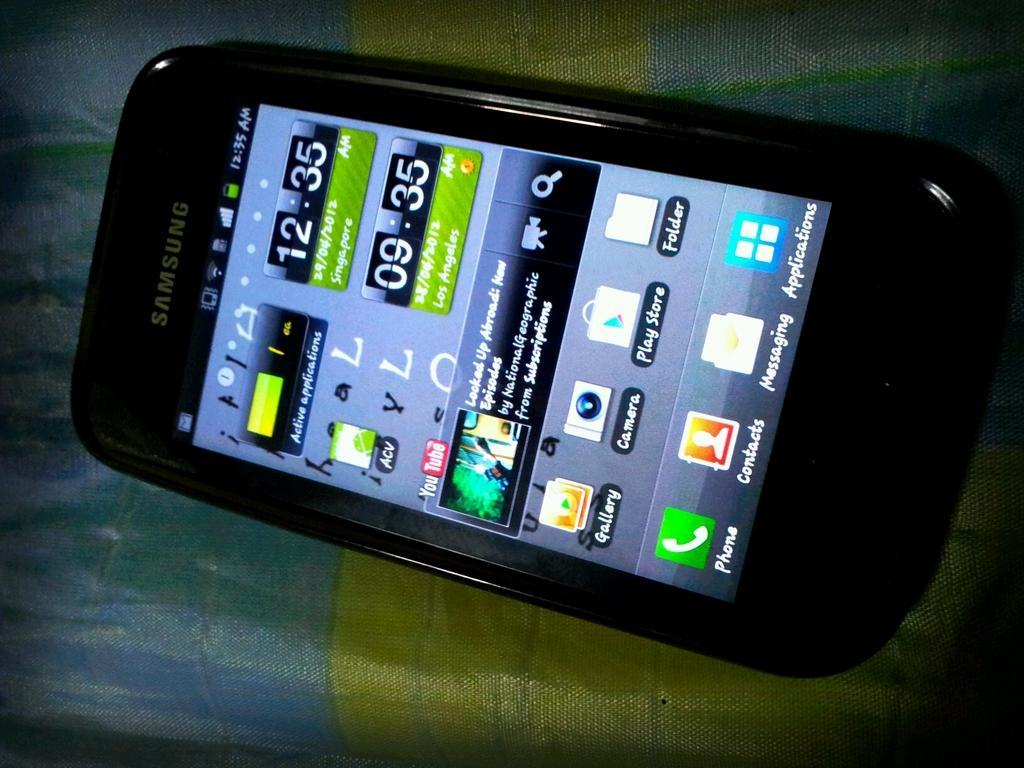In one or two sentences, can you explain what this image depicts? This is a zoomed in picture. In the center we can see a black color mobile phone placed on a cloth and we can see the text, numbers and some pictures and we can see the icons on the display of the mobile phone. 